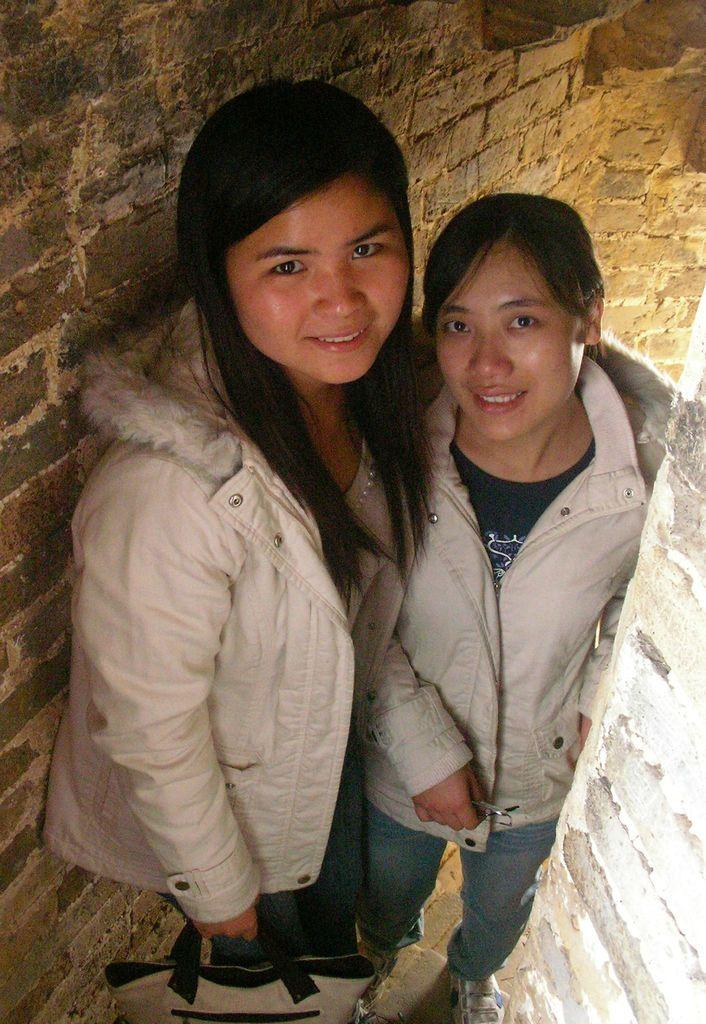What is the person in the image holding? The person in the image is holding a bag. Can you describe the other person in the image? There is another person standing beside the first person. What can be seen in the background of the image? There is a wall visible in the background of the image. What type of slope can be seen in the image? There is no slope present in the image. What thing is the person holding in the image? The person is holding a bag, not a thing. 